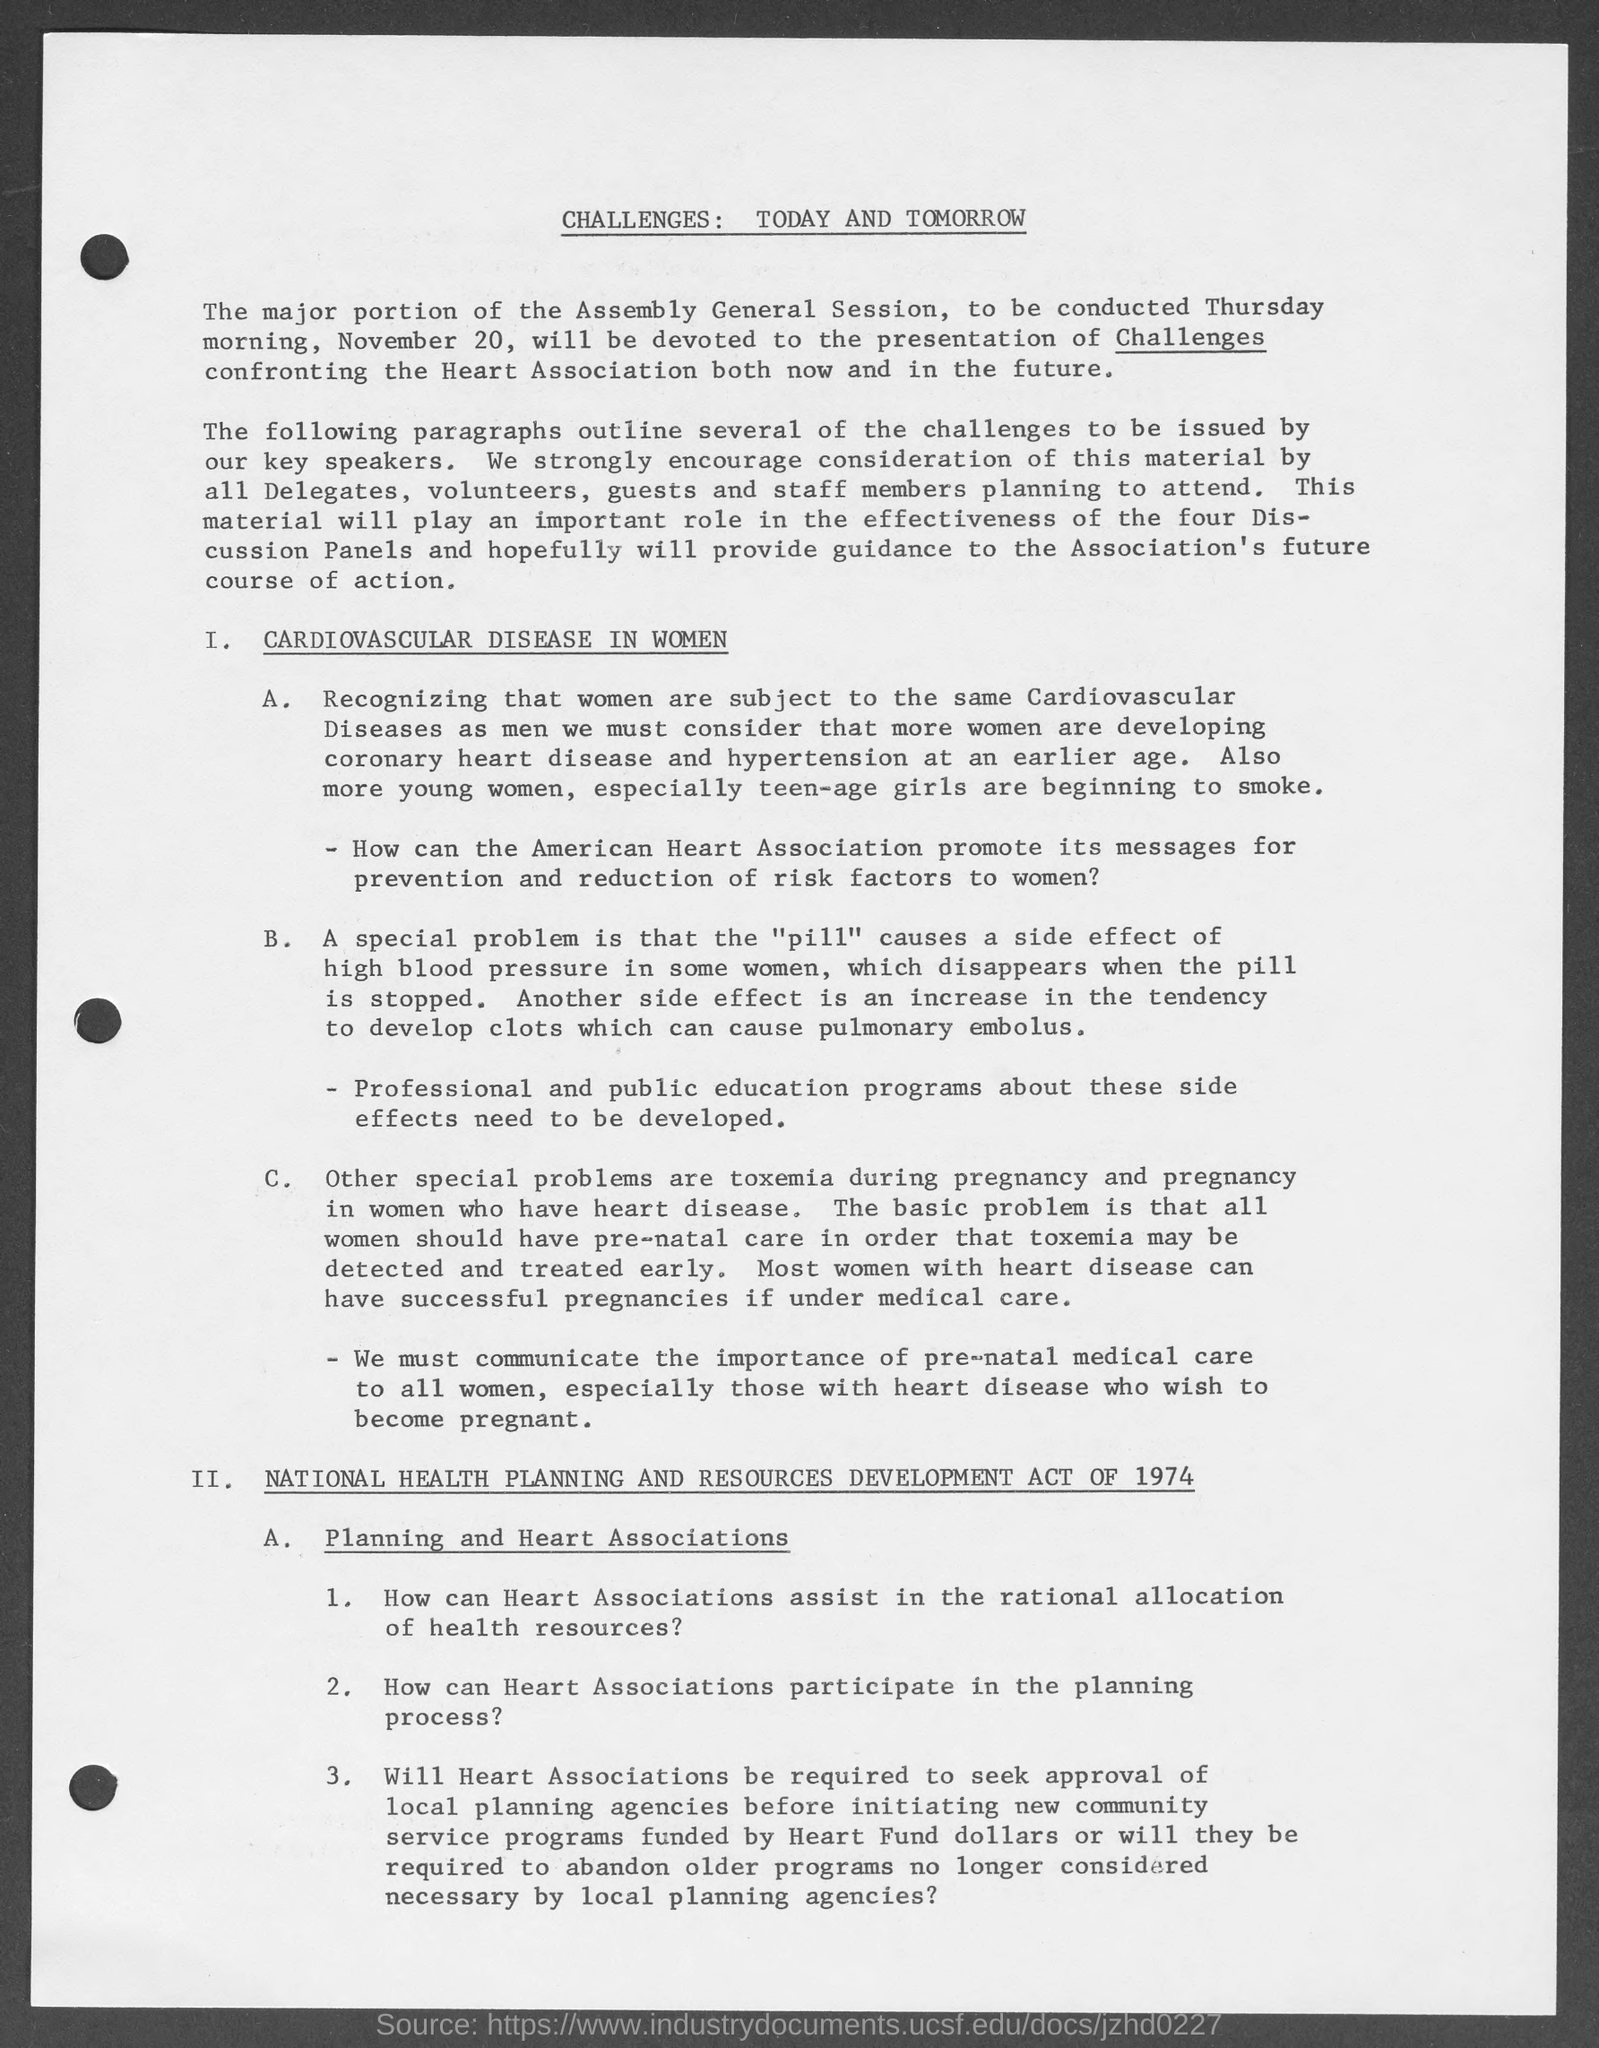What disease is mentioned in women in given document?
Offer a very short reply. Cardiovascular disease. On what day of the week this general assembly session took place?
Offer a very short reply. Thursday. National health planning and resources development Act came into force in which year?
Your response must be concise. 1974. What causes side effect of high blood pressure in some women?
Provide a succinct answer. "pill". What is the heading of document?
Your answer should be very brief. Challenges: today and tomorrow. 